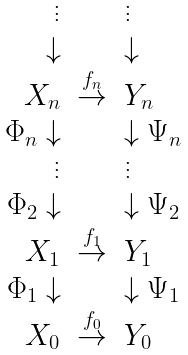Convert formula to latex. <formula><loc_0><loc_0><loc_500><loc_500>\begin{array} { r l l } \vdots & & \vdots \\ \downarrow & & \downarrow \\ X _ { n } & \stackrel { f _ { n } } { \rightarrow } & Y _ { n } \\ \Phi _ { n } \downarrow & & \downarrow \Psi _ { n } \\ \vdots & & \vdots \\ \Phi _ { 2 } \downarrow & & \downarrow \Psi _ { 2 } \\ X _ { 1 } & \stackrel { f _ { 1 } } { \rightarrow } & Y _ { 1 } \\ \Phi _ { 1 } \downarrow & & \downarrow \Psi _ { 1 } \\ X _ { 0 } & \stackrel { f _ { 0 } } { \rightarrow } & Y _ { 0 } \end{array}</formula> 